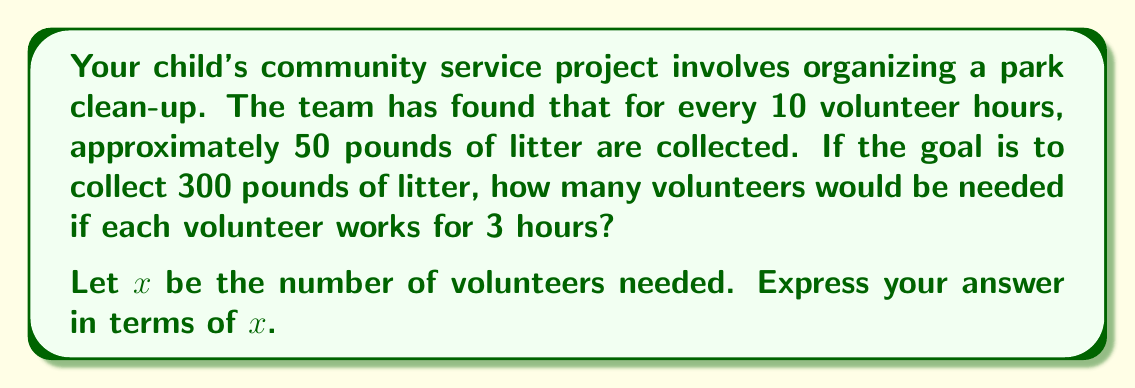Can you answer this question? Let's approach this step-by-step:

1) First, let's establish the relationship between volunteer hours and litter collected:
   10 hours → 50 pounds of litter

2) We need to collect 300 pounds of litter. Let's find out how many volunteer hours this requires:
   $\frac{300\text{ pounds}}{50\text{ pounds/10 hours}} = 60\text{ hours}$

3) Now, we know we need 60 total volunteer hours to meet our goal.

4) Each volunteer works for 3 hours. So, to find the number of volunteers needed:
   $60\text{ total hours} = 3\text{ hours/volunteer} \times x\text{ volunteers}$

5) Solving for $x$:
   $x = \frac{60\text{ hours}}{3\text{ hours/volunteer}} = 20\text{ volunteers}$

Therefore, 20 volunteers working 3 hours each would be needed to collect 300 pounds of litter.
Answer: $x = 20$ 